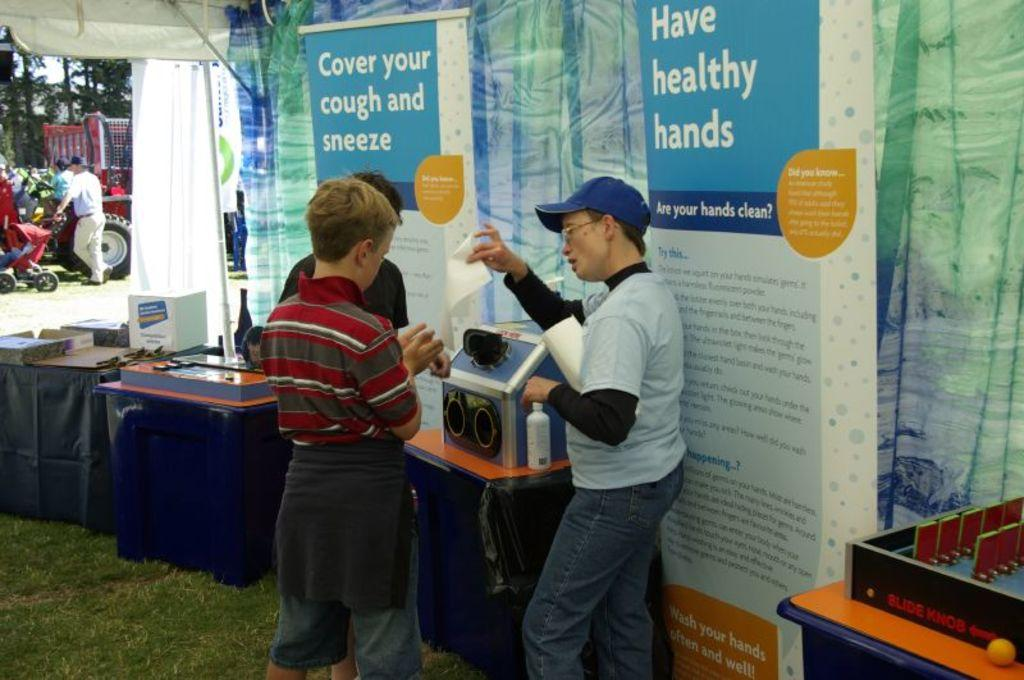<image>
Give a short and clear explanation of the subsequent image. A person handing out flyers promoting the practice to cover your cough and sneeze and have healthy hands. 